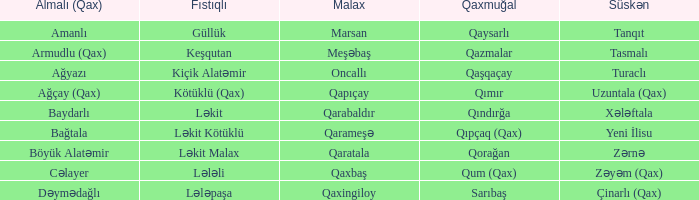What is the Almali village with the Süskən village zərnə? Böyük Alatəmir. 